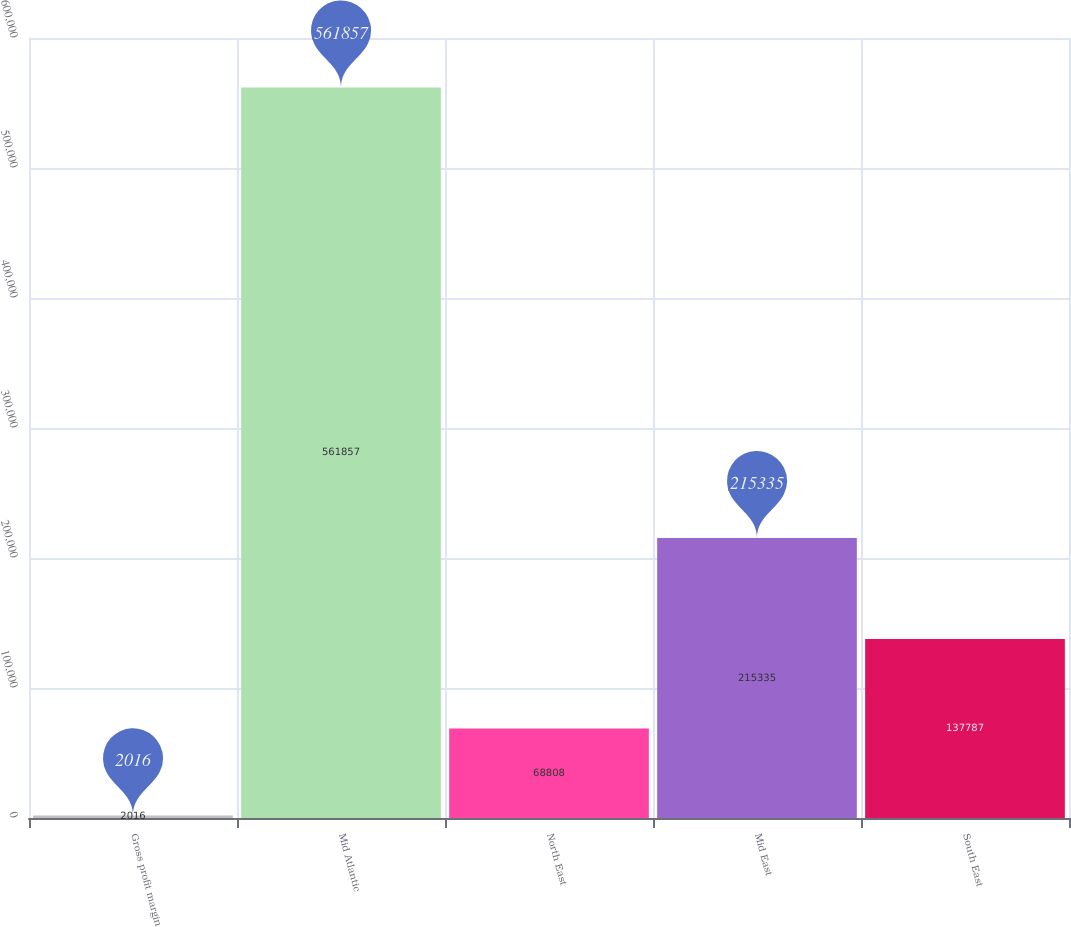<chart> <loc_0><loc_0><loc_500><loc_500><bar_chart><fcel>Gross profit margin<fcel>Mid Atlantic<fcel>North East<fcel>Mid East<fcel>South East<nl><fcel>2016<fcel>561857<fcel>68808<fcel>215335<fcel>137787<nl></chart> 